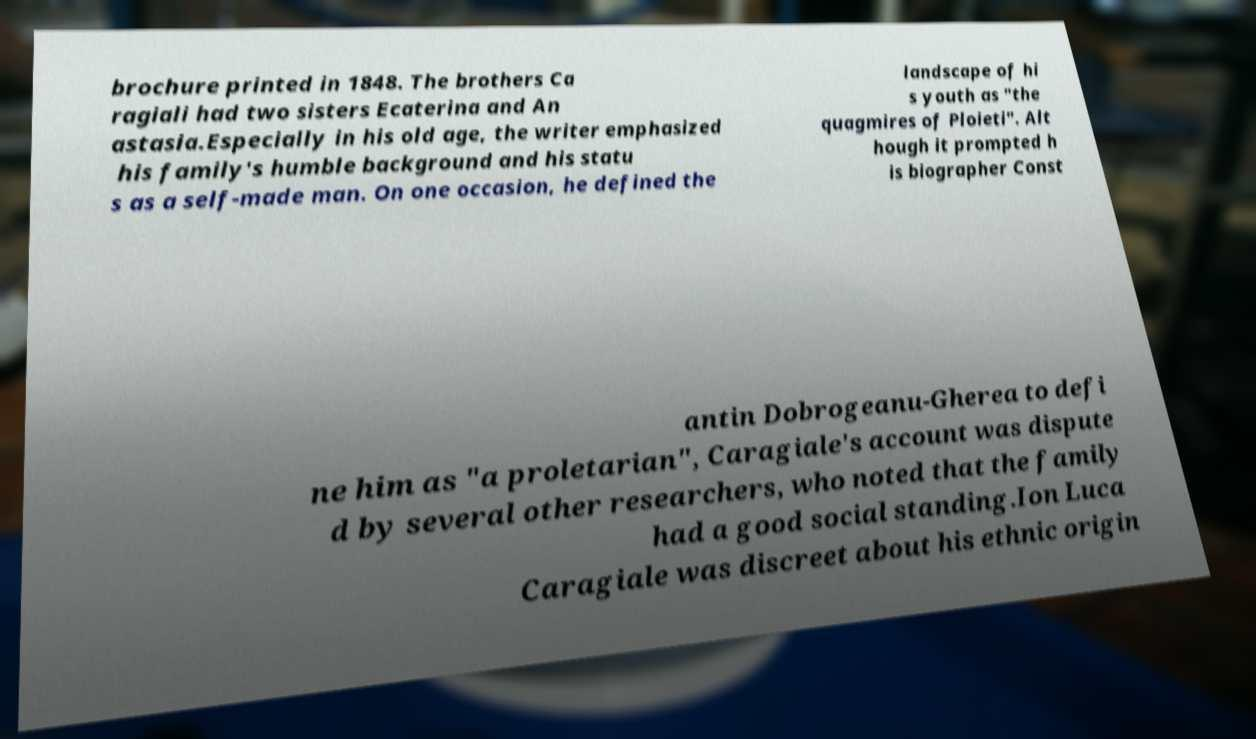Can you accurately transcribe the text from the provided image for me? brochure printed in 1848. The brothers Ca ragiali had two sisters Ecaterina and An astasia.Especially in his old age, the writer emphasized his family's humble background and his statu s as a self-made man. On one occasion, he defined the landscape of hi s youth as "the quagmires of Ploieti". Alt hough it prompted h is biographer Const antin Dobrogeanu-Gherea to defi ne him as "a proletarian", Caragiale's account was dispute d by several other researchers, who noted that the family had a good social standing.Ion Luca Caragiale was discreet about his ethnic origin 